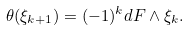Convert formula to latex. <formula><loc_0><loc_0><loc_500><loc_500>\theta ( \xi _ { k + 1 } ) = ( - 1 ) ^ { k } d F \wedge \xi _ { k } .</formula> 